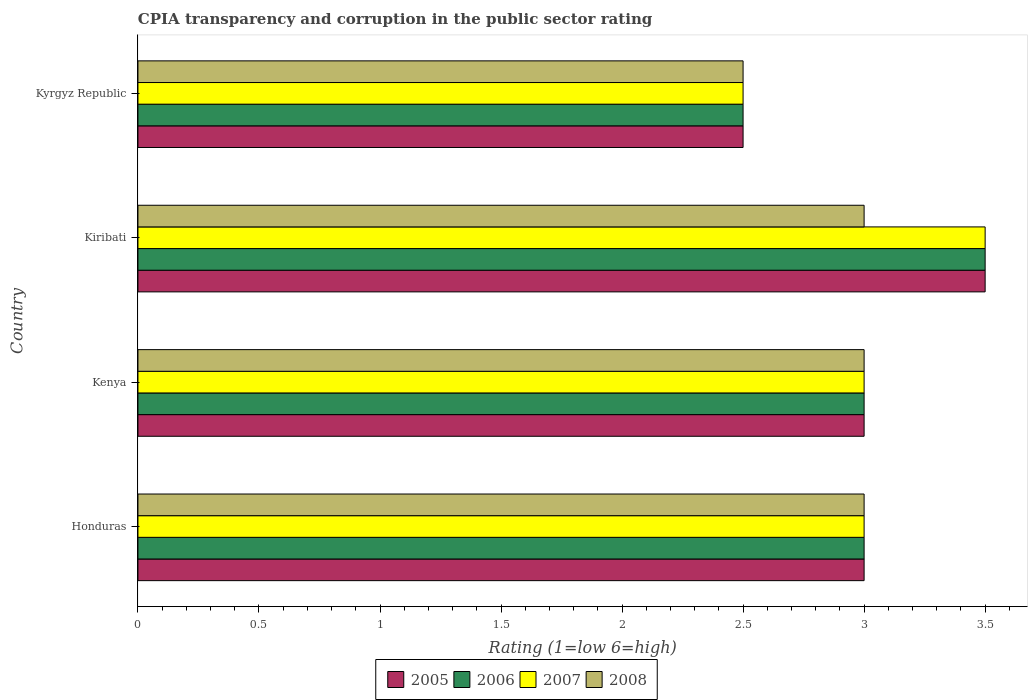How many groups of bars are there?
Your response must be concise. 4. Are the number of bars per tick equal to the number of legend labels?
Provide a short and direct response. Yes. How many bars are there on the 1st tick from the top?
Ensure brevity in your answer.  4. How many bars are there on the 2nd tick from the bottom?
Your response must be concise. 4. What is the label of the 3rd group of bars from the top?
Offer a terse response. Kenya. What is the CPIA rating in 2007 in Kiribati?
Your answer should be compact. 3.5. Across all countries, what is the maximum CPIA rating in 2008?
Ensure brevity in your answer.  3. In which country was the CPIA rating in 2008 maximum?
Your answer should be compact. Honduras. In which country was the CPIA rating in 2006 minimum?
Provide a short and direct response. Kyrgyz Republic. What is the total CPIA rating in 2008 in the graph?
Ensure brevity in your answer.  11.5. What is the difference between the CPIA rating in 2008 in Honduras and that in Kenya?
Ensure brevity in your answer.  0. What is the average CPIA rating in 2007 per country?
Your answer should be very brief. 3. Is the difference between the CPIA rating in 2006 in Kenya and Kyrgyz Republic greater than the difference between the CPIA rating in 2007 in Kenya and Kyrgyz Republic?
Your answer should be very brief. No. What is the difference between the highest and the second highest CPIA rating in 2006?
Give a very brief answer. 0.5. In how many countries, is the CPIA rating in 2006 greater than the average CPIA rating in 2006 taken over all countries?
Provide a succinct answer. 1. Is the sum of the CPIA rating in 2005 in Honduras and Kyrgyz Republic greater than the maximum CPIA rating in 2008 across all countries?
Your answer should be very brief. Yes. What does the 3rd bar from the top in Kiribati represents?
Provide a short and direct response. 2006. What does the 1st bar from the bottom in Kiribati represents?
Make the answer very short. 2005. Is it the case that in every country, the sum of the CPIA rating in 2006 and CPIA rating in 2008 is greater than the CPIA rating in 2007?
Your answer should be compact. Yes. How many bars are there?
Make the answer very short. 16. Are the values on the major ticks of X-axis written in scientific E-notation?
Offer a terse response. No. Does the graph contain any zero values?
Ensure brevity in your answer.  No. Where does the legend appear in the graph?
Your answer should be compact. Bottom center. What is the title of the graph?
Provide a succinct answer. CPIA transparency and corruption in the public sector rating. Does "1980" appear as one of the legend labels in the graph?
Offer a very short reply. No. What is the label or title of the X-axis?
Give a very brief answer. Rating (1=low 6=high). What is the label or title of the Y-axis?
Give a very brief answer. Country. What is the Rating (1=low 6=high) of 2007 in Honduras?
Your response must be concise. 3. What is the Rating (1=low 6=high) in 2008 in Honduras?
Provide a short and direct response. 3. What is the Rating (1=low 6=high) of 2006 in Kenya?
Your answer should be very brief. 3. What is the Rating (1=low 6=high) in 2007 in Kenya?
Make the answer very short. 3. What is the Rating (1=low 6=high) in 2007 in Kiribati?
Ensure brevity in your answer.  3.5. What is the Rating (1=low 6=high) in 2006 in Kyrgyz Republic?
Your answer should be very brief. 2.5. What is the Rating (1=low 6=high) in 2007 in Kyrgyz Republic?
Your response must be concise. 2.5. What is the Rating (1=low 6=high) of 2008 in Kyrgyz Republic?
Your response must be concise. 2.5. Across all countries, what is the maximum Rating (1=low 6=high) of 2008?
Offer a very short reply. 3. Across all countries, what is the minimum Rating (1=low 6=high) of 2006?
Keep it short and to the point. 2.5. Across all countries, what is the minimum Rating (1=low 6=high) in 2007?
Your response must be concise. 2.5. What is the total Rating (1=low 6=high) of 2006 in the graph?
Your answer should be very brief. 12. What is the total Rating (1=low 6=high) in 2008 in the graph?
Offer a terse response. 11.5. What is the difference between the Rating (1=low 6=high) in 2005 in Honduras and that in Kenya?
Your response must be concise. 0. What is the difference between the Rating (1=low 6=high) in 2006 in Honduras and that in Kenya?
Keep it short and to the point. 0. What is the difference between the Rating (1=low 6=high) in 2007 in Honduras and that in Kenya?
Your response must be concise. 0. What is the difference between the Rating (1=low 6=high) in 2005 in Honduras and that in Kiribati?
Provide a succinct answer. -0.5. What is the difference between the Rating (1=low 6=high) of 2006 in Honduras and that in Kiribati?
Ensure brevity in your answer.  -0.5. What is the difference between the Rating (1=low 6=high) in 2007 in Honduras and that in Kiribati?
Ensure brevity in your answer.  -0.5. What is the difference between the Rating (1=low 6=high) of 2005 in Honduras and that in Kyrgyz Republic?
Give a very brief answer. 0.5. What is the difference between the Rating (1=low 6=high) of 2008 in Honduras and that in Kyrgyz Republic?
Make the answer very short. 0.5. What is the difference between the Rating (1=low 6=high) of 2005 in Kenya and that in Kiribati?
Your answer should be compact. -0.5. What is the difference between the Rating (1=low 6=high) in 2007 in Kenya and that in Kiribati?
Your answer should be very brief. -0.5. What is the difference between the Rating (1=low 6=high) in 2005 in Kenya and that in Kyrgyz Republic?
Make the answer very short. 0.5. What is the difference between the Rating (1=low 6=high) of 2006 in Kenya and that in Kyrgyz Republic?
Your answer should be very brief. 0.5. What is the difference between the Rating (1=low 6=high) of 2007 in Kenya and that in Kyrgyz Republic?
Give a very brief answer. 0.5. What is the difference between the Rating (1=low 6=high) in 2008 in Kenya and that in Kyrgyz Republic?
Ensure brevity in your answer.  0.5. What is the difference between the Rating (1=low 6=high) in 2005 in Kiribati and that in Kyrgyz Republic?
Your answer should be very brief. 1. What is the difference between the Rating (1=low 6=high) in 2006 in Kiribati and that in Kyrgyz Republic?
Provide a short and direct response. 1. What is the difference between the Rating (1=low 6=high) in 2005 in Honduras and the Rating (1=low 6=high) in 2006 in Kenya?
Offer a terse response. 0. What is the difference between the Rating (1=low 6=high) in 2005 in Honduras and the Rating (1=low 6=high) in 2007 in Kenya?
Make the answer very short. 0. What is the difference between the Rating (1=low 6=high) in 2006 in Honduras and the Rating (1=low 6=high) in 2007 in Kenya?
Offer a very short reply. 0. What is the difference between the Rating (1=low 6=high) in 2006 in Honduras and the Rating (1=low 6=high) in 2008 in Kenya?
Keep it short and to the point. 0. What is the difference between the Rating (1=low 6=high) of 2007 in Honduras and the Rating (1=low 6=high) of 2008 in Kenya?
Your answer should be very brief. 0. What is the difference between the Rating (1=low 6=high) of 2005 in Honduras and the Rating (1=low 6=high) of 2007 in Kiribati?
Your answer should be compact. -0.5. What is the difference between the Rating (1=low 6=high) of 2005 in Honduras and the Rating (1=low 6=high) of 2008 in Kiribati?
Provide a short and direct response. 0. What is the difference between the Rating (1=low 6=high) in 2006 in Honduras and the Rating (1=low 6=high) in 2008 in Kiribati?
Your response must be concise. 0. What is the difference between the Rating (1=low 6=high) in 2007 in Honduras and the Rating (1=low 6=high) in 2008 in Kiribati?
Ensure brevity in your answer.  0. What is the difference between the Rating (1=low 6=high) of 2005 in Honduras and the Rating (1=low 6=high) of 2006 in Kyrgyz Republic?
Your answer should be very brief. 0.5. What is the difference between the Rating (1=low 6=high) in 2007 in Honduras and the Rating (1=low 6=high) in 2008 in Kyrgyz Republic?
Make the answer very short. 0.5. What is the difference between the Rating (1=low 6=high) in 2005 in Kenya and the Rating (1=low 6=high) in 2006 in Kiribati?
Give a very brief answer. -0.5. What is the difference between the Rating (1=low 6=high) of 2005 in Kenya and the Rating (1=low 6=high) of 2007 in Kiribati?
Offer a terse response. -0.5. What is the difference between the Rating (1=low 6=high) in 2005 in Kenya and the Rating (1=low 6=high) in 2008 in Kiribati?
Your answer should be very brief. 0. What is the difference between the Rating (1=low 6=high) in 2006 in Kenya and the Rating (1=low 6=high) in 2008 in Kiribati?
Provide a succinct answer. 0. What is the difference between the Rating (1=low 6=high) in 2007 in Kenya and the Rating (1=low 6=high) in 2008 in Kiribati?
Give a very brief answer. 0. What is the difference between the Rating (1=low 6=high) of 2005 in Kenya and the Rating (1=low 6=high) of 2006 in Kyrgyz Republic?
Make the answer very short. 0.5. What is the difference between the Rating (1=low 6=high) in 2005 in Kenya and the Rating (1=low 6=high) in 2008 in Kyrgyz Republic?
Your answer should be compact. 0.5. What is the difference between the Rating (1=low 6=high) in 2006 in Kenya and the Rating (1=low 6=high) in 2007 in Kyrgyz Republic?
Offer a terse response. 0.5. What is the difference between the Rating (1=low 6=high) in 2006 in Kiribati and the Rating (1=low 6=high) in 2007 in Kyrgyz Republic?
Provide a succinct answer. 1. What is the difference between the Rating (1=low 6=high) of 2006 in Kiribati and the Rating (1=low 6=high) of 2008 in Kyrgyz Republic?
Offer a very short reply. 1. What is the average Rating (1=low 6=high) in 2005 per country?
Give a very brief answer. 3. What is the average Rating (1=low 6=high) in 2008 per country?
Offer a very short reply. 2.88. What is the difference between the Rating (1=low 6=high) of 2005 and Rating (1=low 6=high) of 2006 in Honduras?
Make the answer very short. 0. What is the difference between the Rating (1=low 6=high) in 2005 and Rating (1=low 6=high) in 2007 in Honduras?
Your answer should be very brief. 0. What is the difference between the Rating (1=low 6=high) in 2007 and Rating (1=low 6=high) in 2008 in Honduras?
Keep it short and to the point. 0. What is the difference between the Rating (1=low 6=high) in 2005 and Rating (1=low 6=high) in 2006 in Kenya?
Provide a succinct answer. 0. What is the difference between the Rating (1=low 6=high) of 2005 and Rating (1=low 6=high) of 2007 in Kenya?
Your answer should be compact. 0. What is the difference between the Rating (1=low 6=high) of 2005 and Rating (1=low 6=high) of 2008 in Kenya?
Offer a very short reply. 0. What is the difference between the Rating (1=low 6=high) of 2005 and Rating (1=low 6=high) of 2007 in Kiribati?
Your answer should be very brief. 0. What is the difference between the Rating (1=low 6=high) of 2006 and Rating (1=low 6=high) of 2007 in Kiribati?
Provide a succinct answer. 0. What is the difference between the Rating (1=low 6=high) of 2007 and Rating (1=low 6=high) of 2008 in Kiribati?
Provide a succinct answer. 0.5. What is the difference between the Rating (1=low 6=high) of 2005 and Rating (1=low 6=high) of 2006 in Kyrgyz Republic?
Make the answer very short. 0. What is the difference between the Rating (1=low 6=high) of 2005 and Rating (1=low 6=high) of 2008 in Kyrgyz Republic?
Keep it short and to the point. 0. What is the difference between the Rating (1=low 6=high) of 2006 and Rating (1=low 6=high) of 2007 in Kyrgyz Republic?
Offer a very short reply. 0. What is the difference between the Rating (1=low 6=high) of 2006 and Rating (1=low 6=high) of 2008 in Kyrgyz Republic?
Provide a succinct answer. 0. What is the ratio of the Rating (1=low 6=high) of 2005 in Honduras to that in Kenya?
Provide a short and direct response. 1. What is the ratio of the Rating (1=low 6=high) in 2006 in Honduras to that in Kenya?
Provide a succinct answer. 1. What is the ratio of the Rating (1=low 6=high) of 2007 in Honduras to that in Kenya?
Your response must be concise. 1. What is the ratio of the Rating (1=low 6=high) in 2008 in Honduras to that in Kenya?
Ensure brevity in your answer.  1. What is the ratio of the Rating (1=low 6=high) of 2005 in Honduras to that in Kiribati?
Keep it short and to the point. 0.86. What is the ratio of the Rating (1=low 6=high) of 2008 in Honduras to that in Kiribati?
Your answer should be compact. 1. What is the ratio of the Rating (1=low 6=high) in 2006 in Honduras to that in Kyrgyz Republic?
Your answer should be very brief. 1.2. What is the ratio of the Rating (1=low 6=high) of 2007 in Honduras to that in Kyrgyz Republic?
Offer a terse response. 1.2. What is the ratio of the Rating (1=low 6=high) of 2005 in Kenya to that in Kiribati?
Ensure brevity in your answer.  0.86. What is the ratio of the Rating (1=low 6=high) of 2006 in Kenya to that in Kiribati?
Your response must be concise. 0.86. What is the ratio of the Rating (1=low 6=high) in 2008 in Kenya to that in Kyrgyz Republic?
Your response must be concise. 1.2. What is the ratio of the Rating (1=low 6=high) in 2005 in Kiribati to that in Kyrgyz Republic?
Provide a succinct answer. 1.4. What is the ratio of the Rating (1=low 6=high) in 2006 in Kiribati to that in Kyrgyz Republic?
Your answer should be very brief. 1.4. What is the ratio of the Rating (1=low 6=high) of 2008 in Kiribati to that in Kyrgyz Republic?
Make the answer very short. 1.2. What is the difference between the highest and the second highest Rating (1=low 6=high) in 2006?
Ensure brevity in your answer.  0.5. What is the difference between the highest and the second highest Rating (1=low 6=high) in 2007?
Your answer should be very brief. 0.5. What is the difference between the highest and the second highest Rating (1=low 6=high) in 2008?
Your response must be concise. 0. What is the difference between the highest and the lowest Rating (1=low 6=high) in 2005?
Your answer should be very brief. 1. What is the difference between the highest and the lowest Rating (1=low 6=high) of 2007?
Ensure brevity in your answer.  1. 